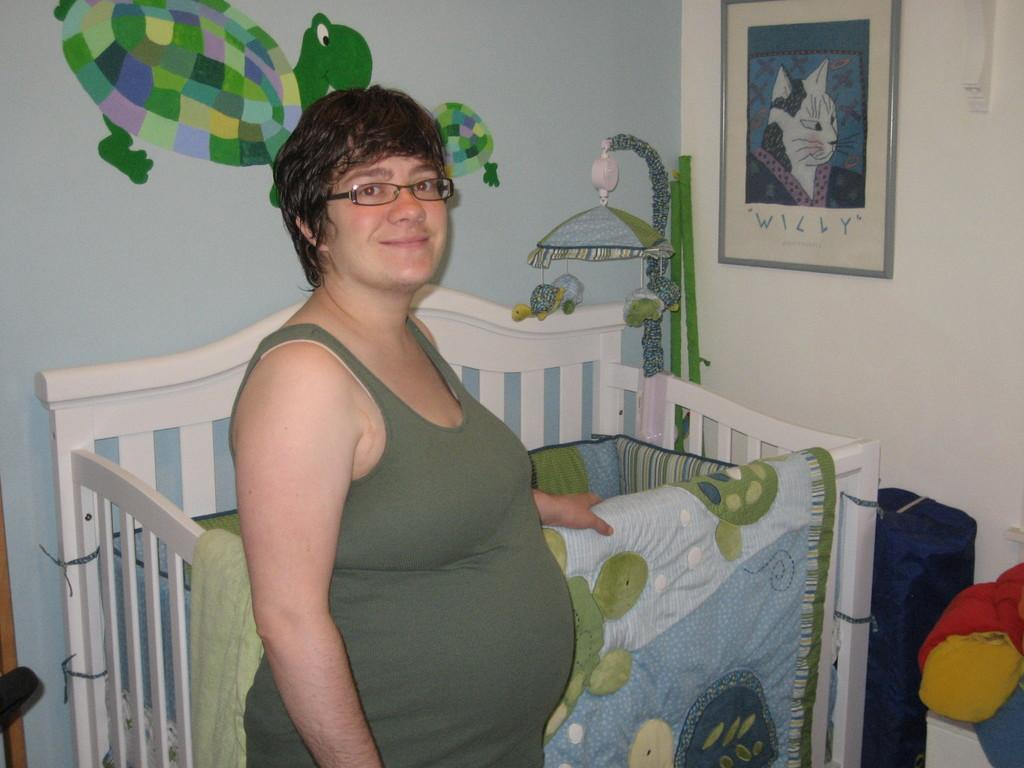Who is the main subject in the foreground of the picture? There is a woman in the foreground of the picture. What object is also present in the foreground of the picture? There is a child's bed in the foreground of the picture. What can be seen on the right side of the picture? There are toys on the right side of the picture. What is visible on the wall in the background of the picture? There is a frame and a poster on the wall in the background of the picture. How does the boy use the lift in the picture? There is no boy or lift present in the picture. 